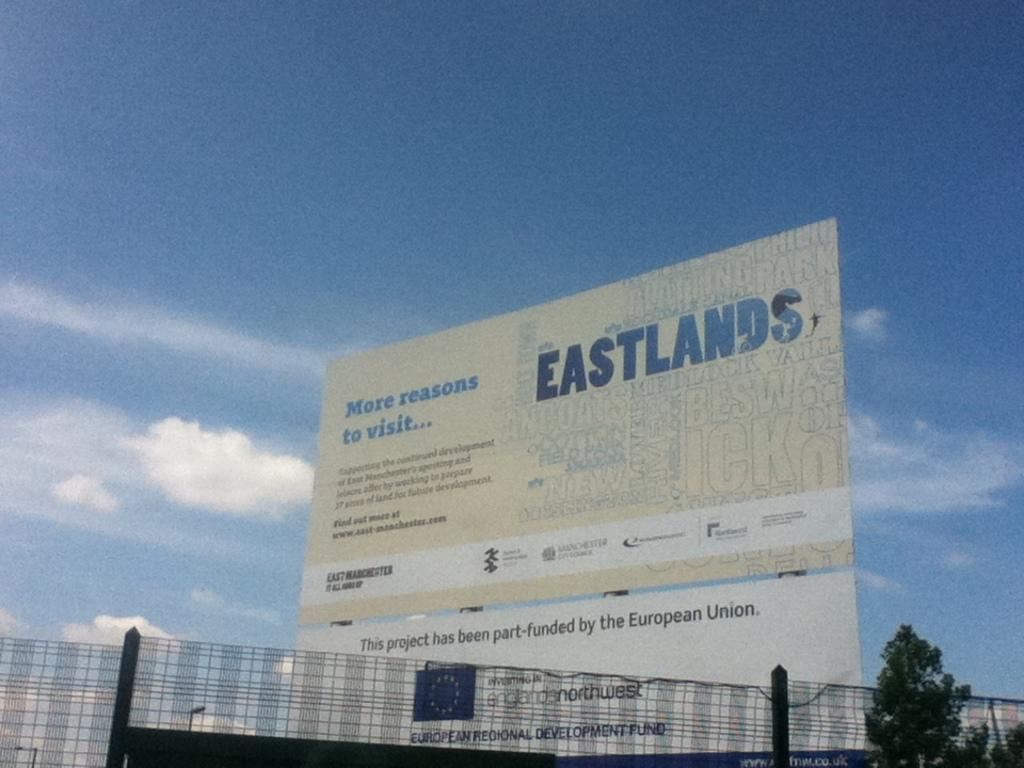<image>
Write a terse but informative summary of the picture. a banner that reads eastlands more reasons to visit 